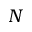Convert formula to latex. <formula><loc_0><loc_0><loc_500><loc_500>N</formula> 